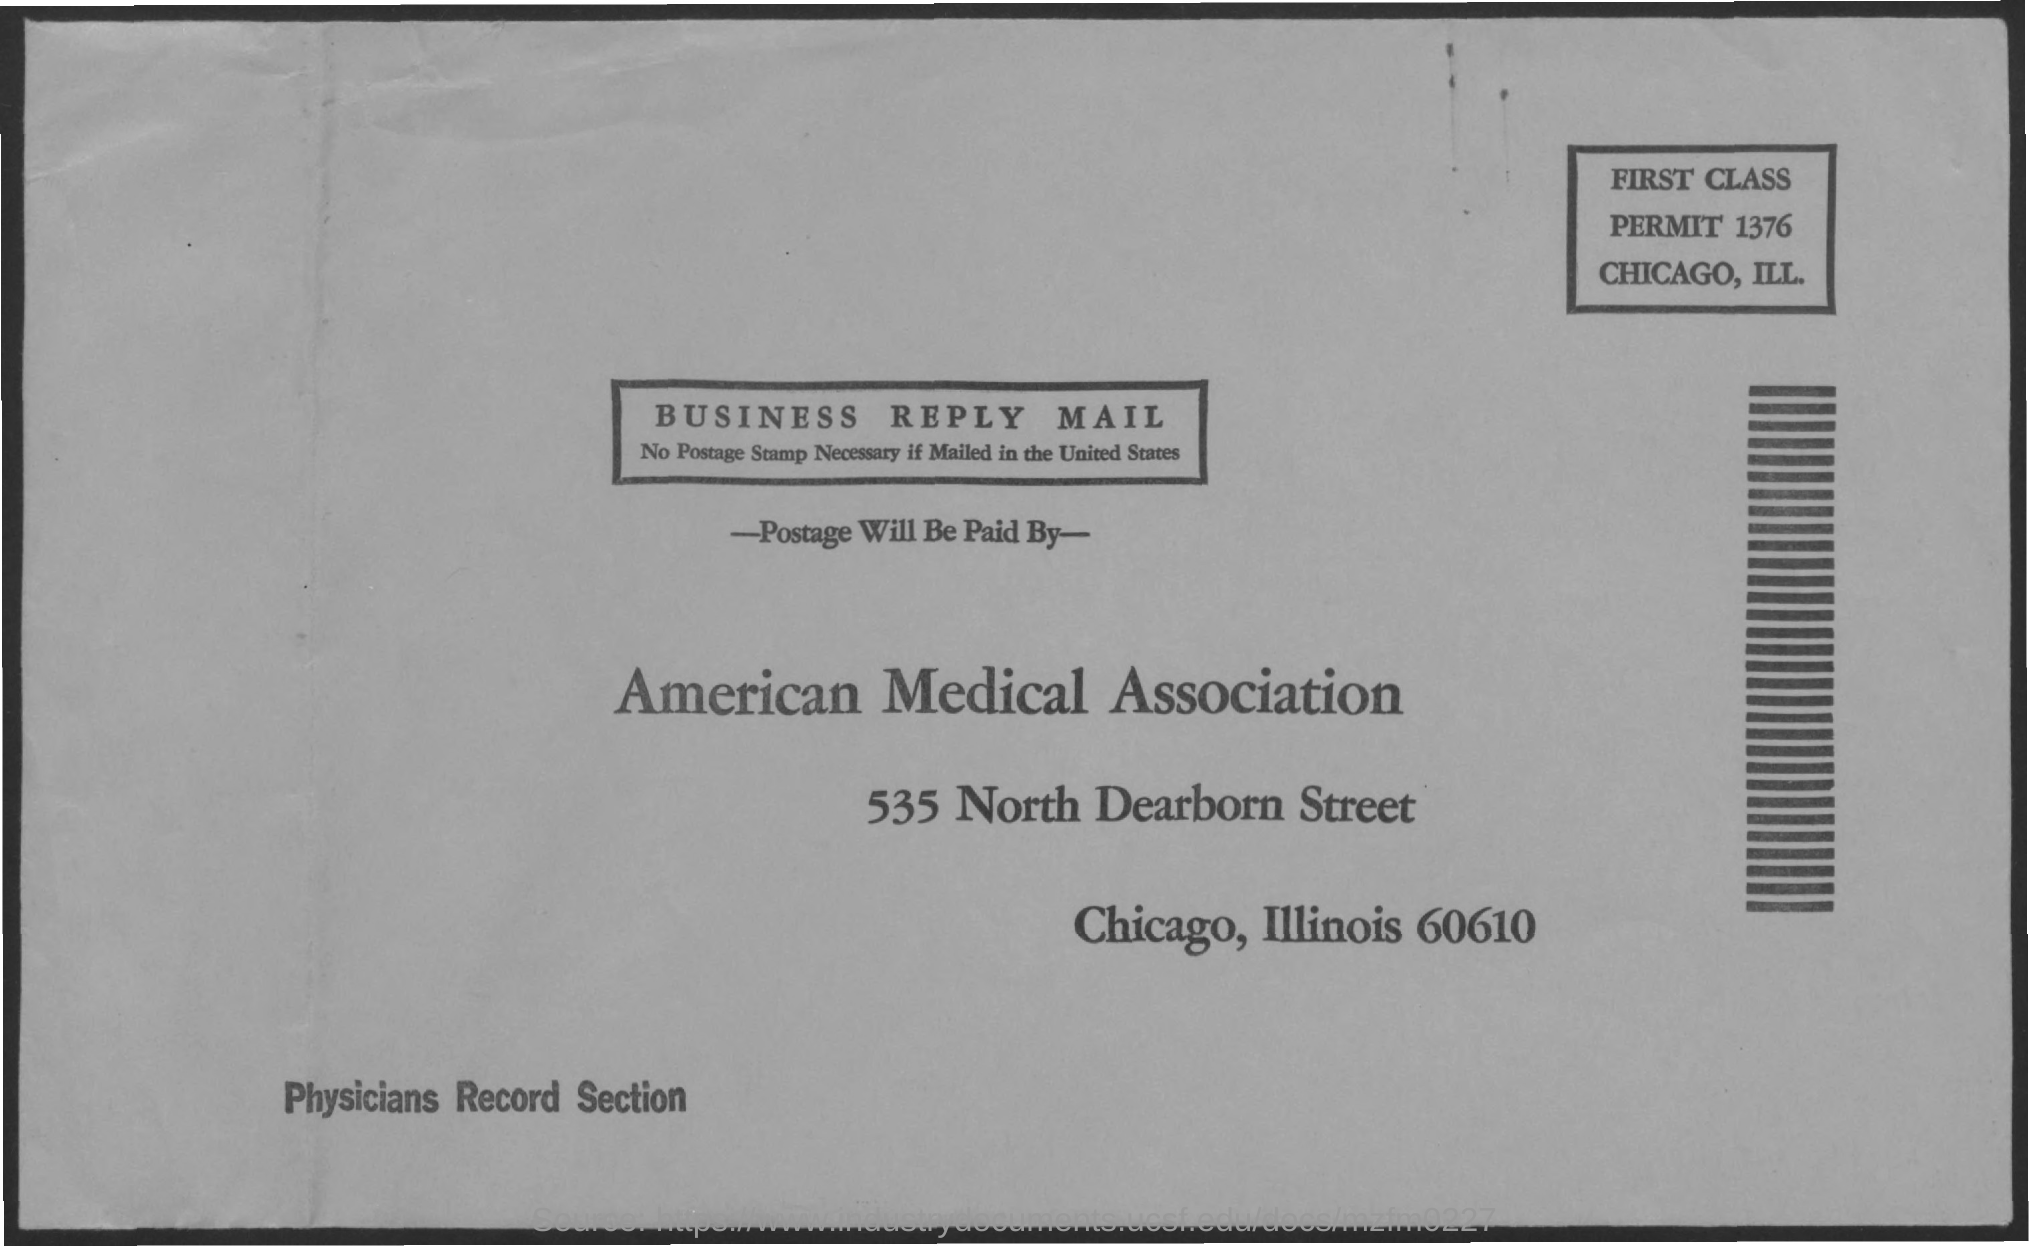What is the first class permit number?
Provide a succinct answer. 1376. 